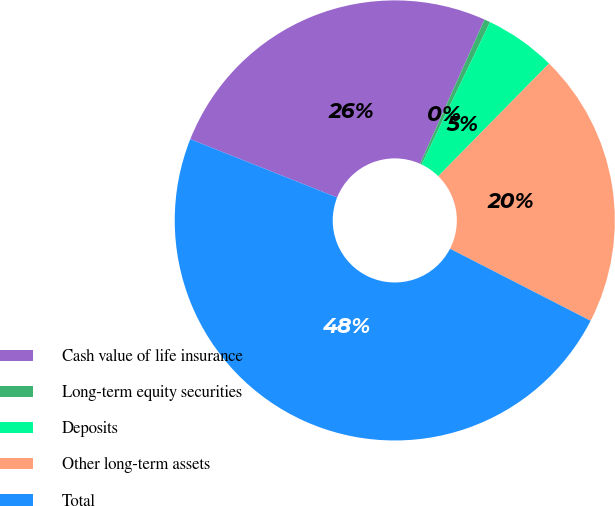Convert chart. <chart><loc_0><loc_0><loc_500><loc_500><pie_chart><fcel>Cash value of life insurance<fcel>Long-term equity securities<fcel>Deposits<fcel>Other long-term assets<fcel>Total<nl><fcel>25.67%<fcel>0.44%<fcel>5.24%<fcel>20.17%<fcel>48.48%<nl></chart> 